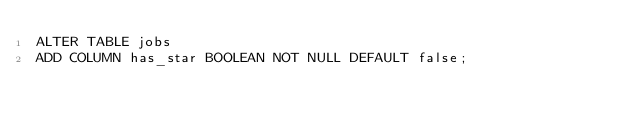Convert code to text. <code><loc_0><loc_0><loc_500><loc_500><_SQL_>ALTER TABLE jobs
ADD COLUMN has_star BOOLEAN NOT NULL DEFAULT false;
</code> 